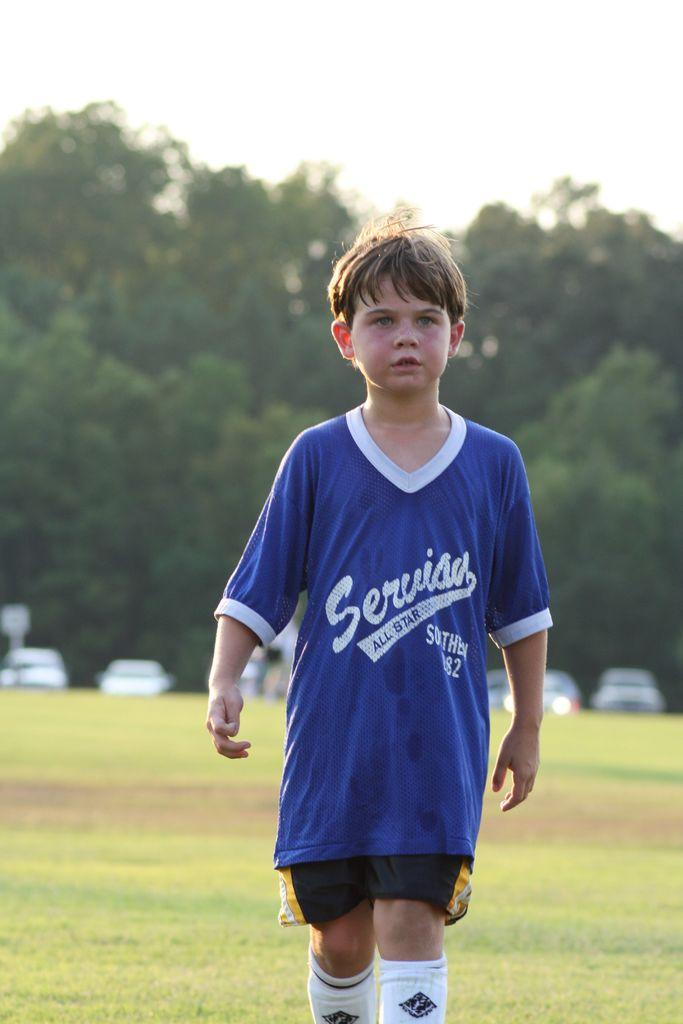<image>
Write a terse but informative summary of the picture. The child playing soccer is playing on an all star team. 